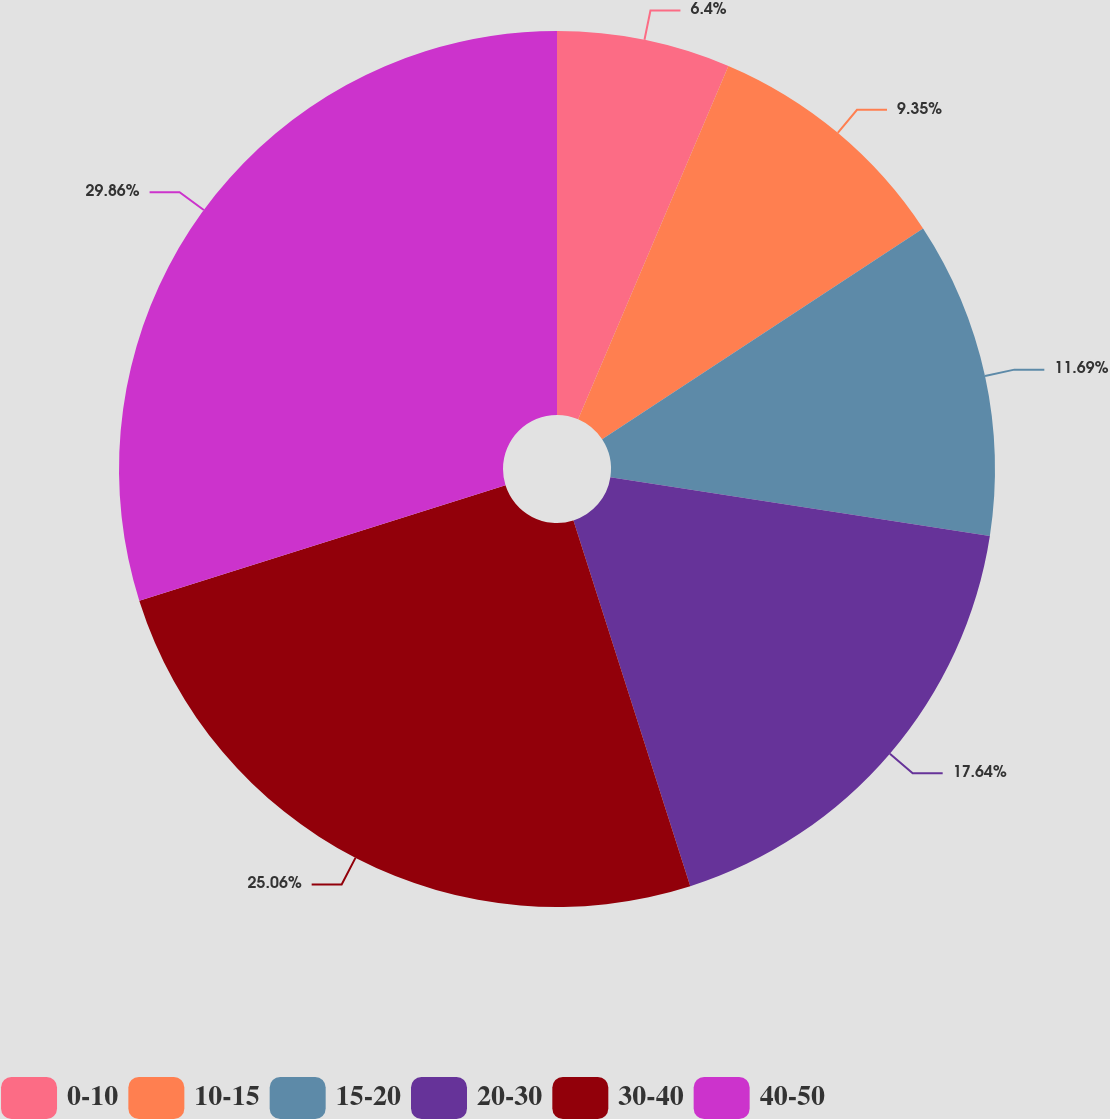Convert chart. <chart><loc_0><loc_0><loc_500><loc_500><pie_chart><fcel>0-10<fcel>10-15<fcel>15-20<fcel>20-30<fcel>30-40<fcel>40-50<nl><fcel>6.4%<fcel>9.35%<fcel>11.69%<fcel>17.64%<fcel>25.06%<fcel>29.86%<nl></chart> 